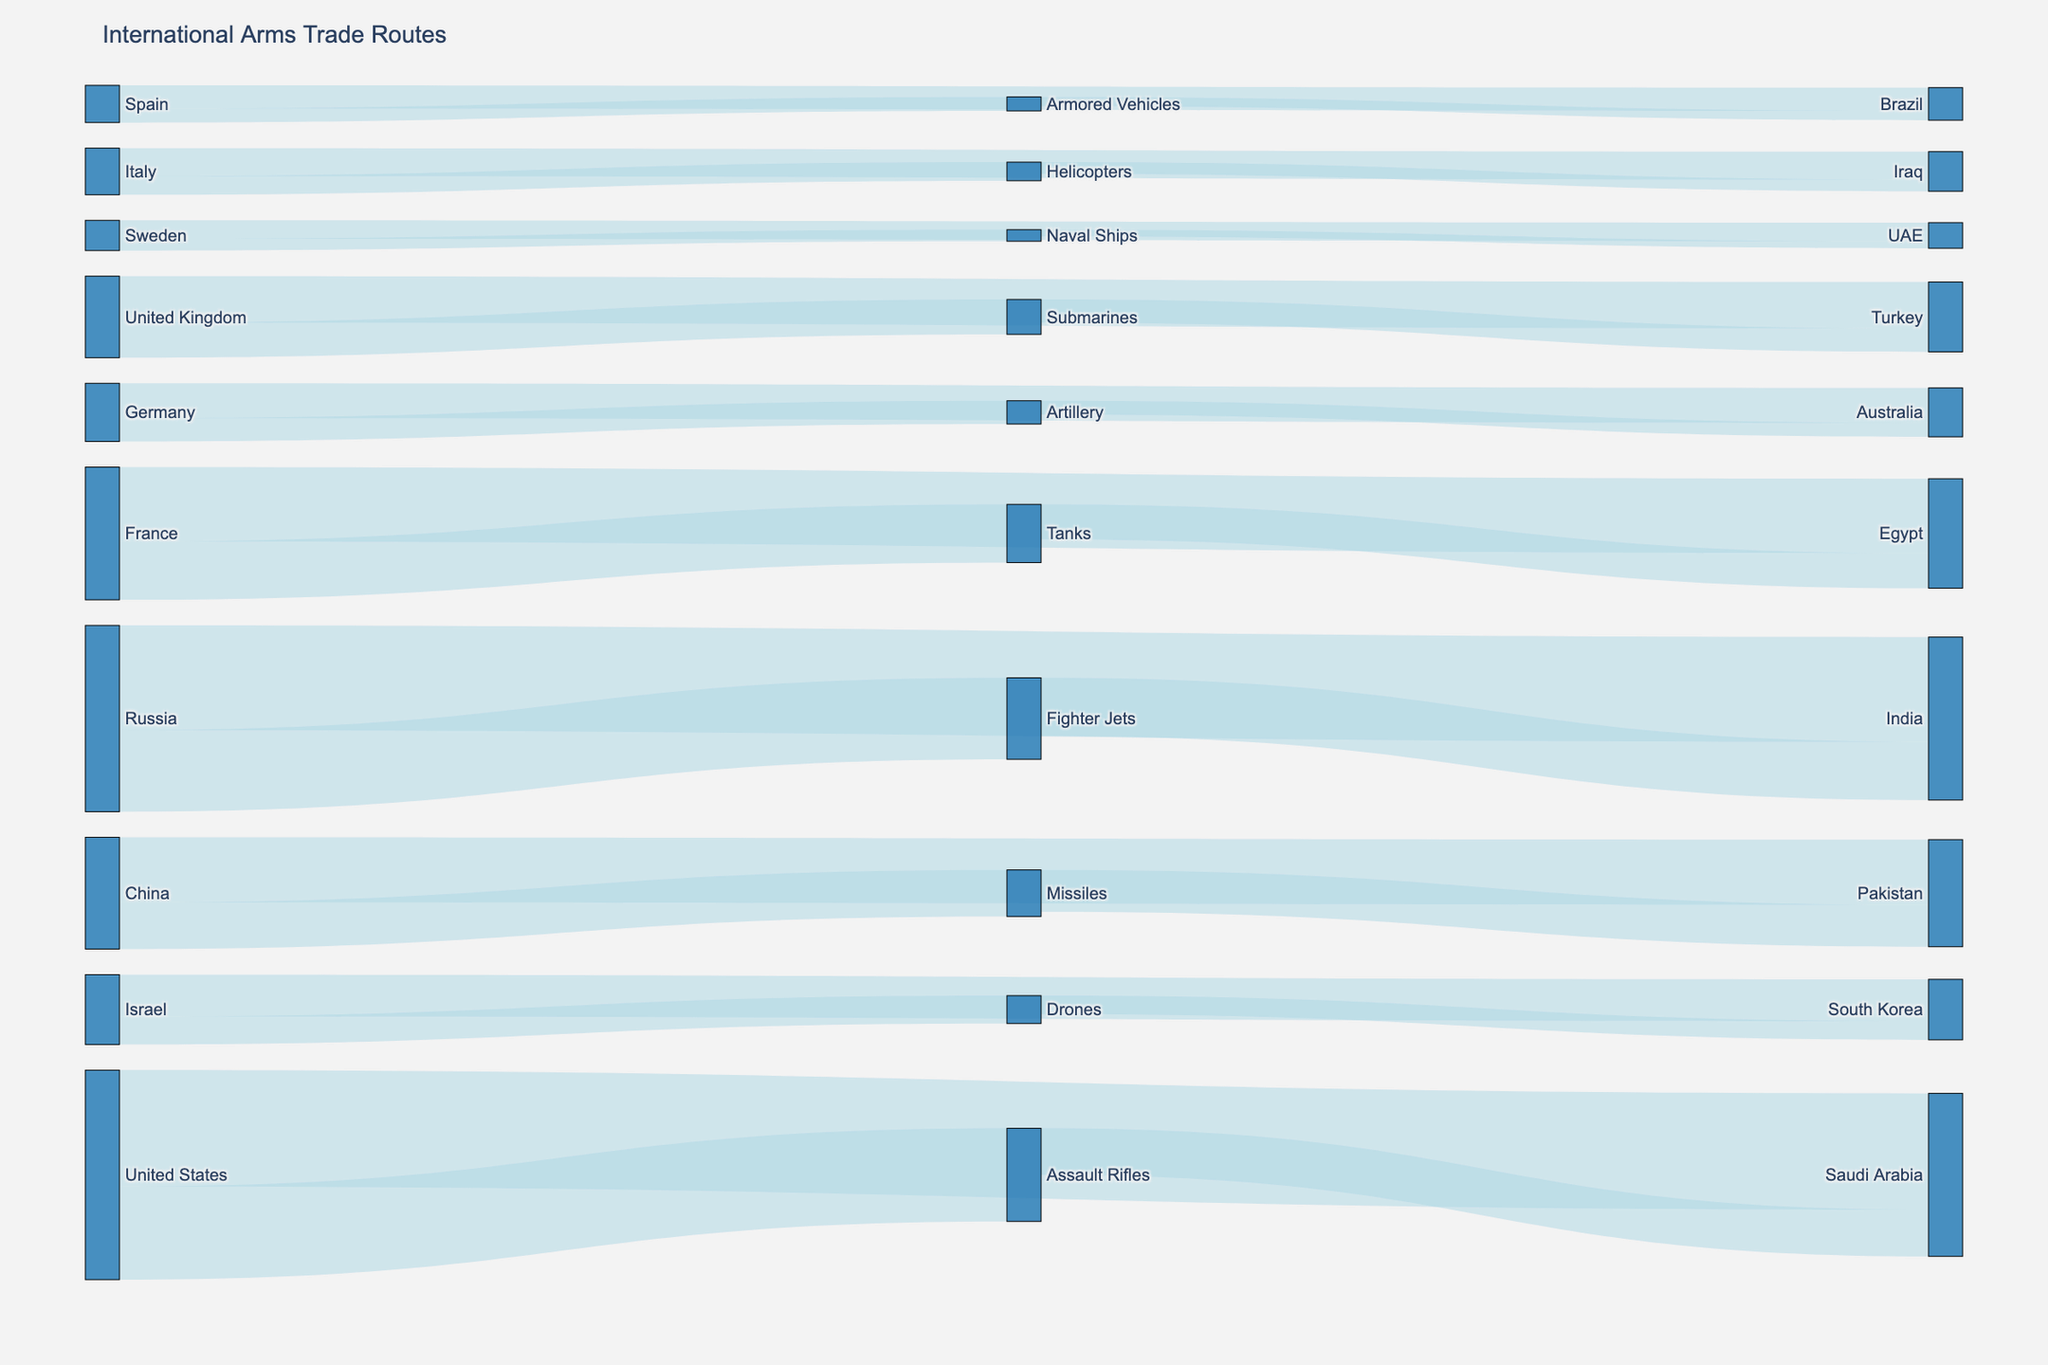what is the title of the figure? The title of the figure is typically located at the top of the diagram. In this case, it reads "International Arms Trade Routes".
Answer: International Arms Trade Routes What weapon type does Russia primarily export? To find this, look for the connection from Russia to a weapon type. The biggest flow from Russia is to Fighter Jets.
Answer: Fighter Jets Which country is the destination for the highest value of arms from the United States? Check the connections starting from the United States to various countries. The largest flow goes to Saudi Arabia with a value of 5000.
Answer: Saudi Arabia Which countries receive tanks from France? Look at the connection from Tanks to its destination. The diagram shows that Egypt receives Tanks from France.
Answer: Egypt What is the total value of arms exported by China? Locate all flows where China is the source. There are two: China to Pakistan (2800) and China to Missiles (2000). Sum these values (2800 + 2000 = 4800).
Answer: 4800 How does the value of arms exported from France to Egypt compare to the value of tanks exported from France? Observe the value from France to Egypt (3200) and the value of Tanks (2500). Compare the two values (3200 is greater than 2500).
Answer: 3200 is greater than 2500 Identify the destination for Assault Rifles. Look at the connection starting from Assault Rifles and see where it leads. Assault Rifles are sent to Saudi Arabia with a value of 2000.
Answer: Saudi Arabia Which country exports the highest value of arms to Turkey? Check all connections leading to Turkey. The United Kingdom has the highest value of arms exported to Turkey with a value of 2000.
Answer: United Kingdom How many different weapon types are detailed in the diagram? Count the different weapon types listed connected to origins and destinations. The weapon types are Assault Rifles, Fighter Jets, Tanks, Missiles, Submarines, Drones, Artillery, Helicopters, Armored Vehicles, and Naval Ships.
Answer: 10 What's the combined value of Drones and Tanks exported from their respective countries? Look at the value of Drones (1200 from Israel) and Tanks (2500 from France). Sum these values (1200 + 2500 = 3700).
Answer: 3700 